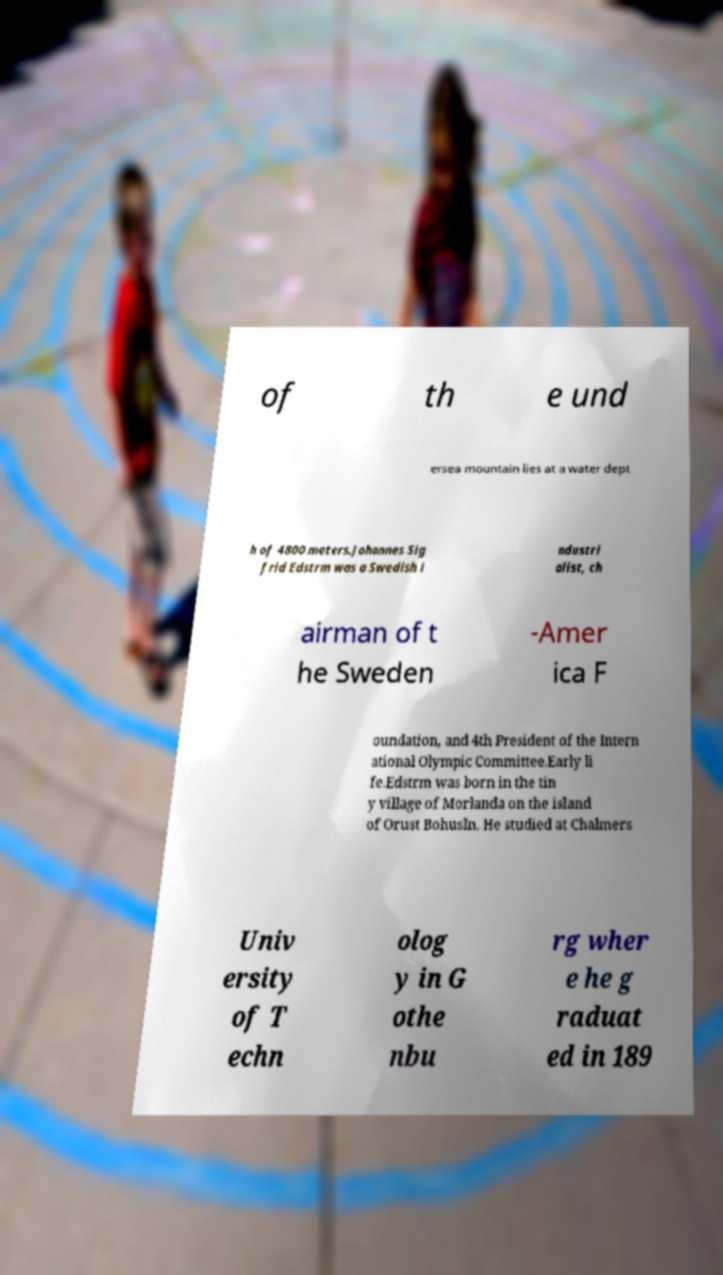What messages or text are displayed in this image? I need them in a readable, typed format. of th e und ersea mountain lies at a water dept h of 4800 meters.Johannes Sig frid Edstrm was a Swedish i ndustri alist, ch airman of t he Sweden -Amer ica F oundation, and 4th President of the Intern ational Olympic Committee.Early li fe.Edstrm was born in the tin y village of Morlanda on the island of Orust Bohusln. He studied at Chalmers Univ ersity of T echn olog y in G othe nbu rg wher e he g raduat ed in 189 